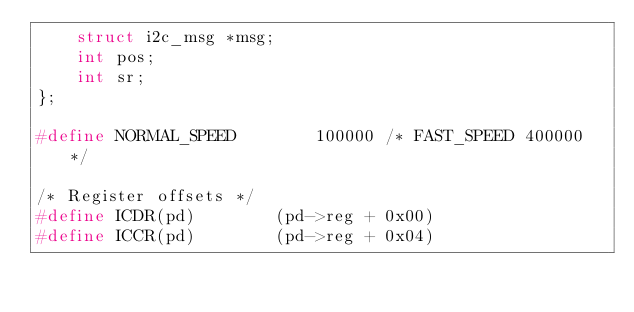<code> <loc_0><loc_0><loc_500><loc_500><_C_>	struct i2c_msg *msg;
	int pos;
	int sr;
};

#define NORMAL_SPEED		100000 /* FAST_SPEED 400000 */

/* Register offsets */
#define ICDR(pd)		(pd->reg + 0x00)
#define ICCR(pd)		(pd->reg + 0x04)</code> 